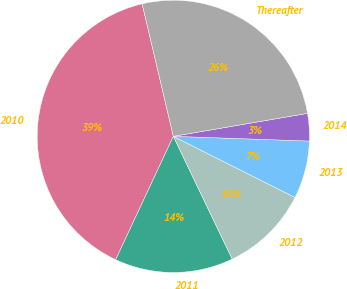<chart> <loc_0><loc_0><loc_500><loc_500><pie_chart><fcel>2010<fcel>2011<fcel>2012<fcel>2013<fcel>2014<fcel>Thereafter<nl><fcel>39.36%<fcel>14.08%<fcel>10.47%<fcel>6.86%<fcel>3.25%<fcel>25.98%<nl></chart> 